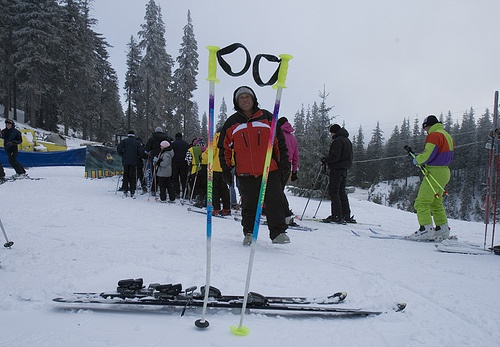Describe the objects in this image and their specific colors. I can see people in black, maroon, gray, and darkgray tones, skis in black, darkgray, and gray tones, people in black, green, olive, and navy tones, people in black and gray tones, and people in black and olive tones in this image. 